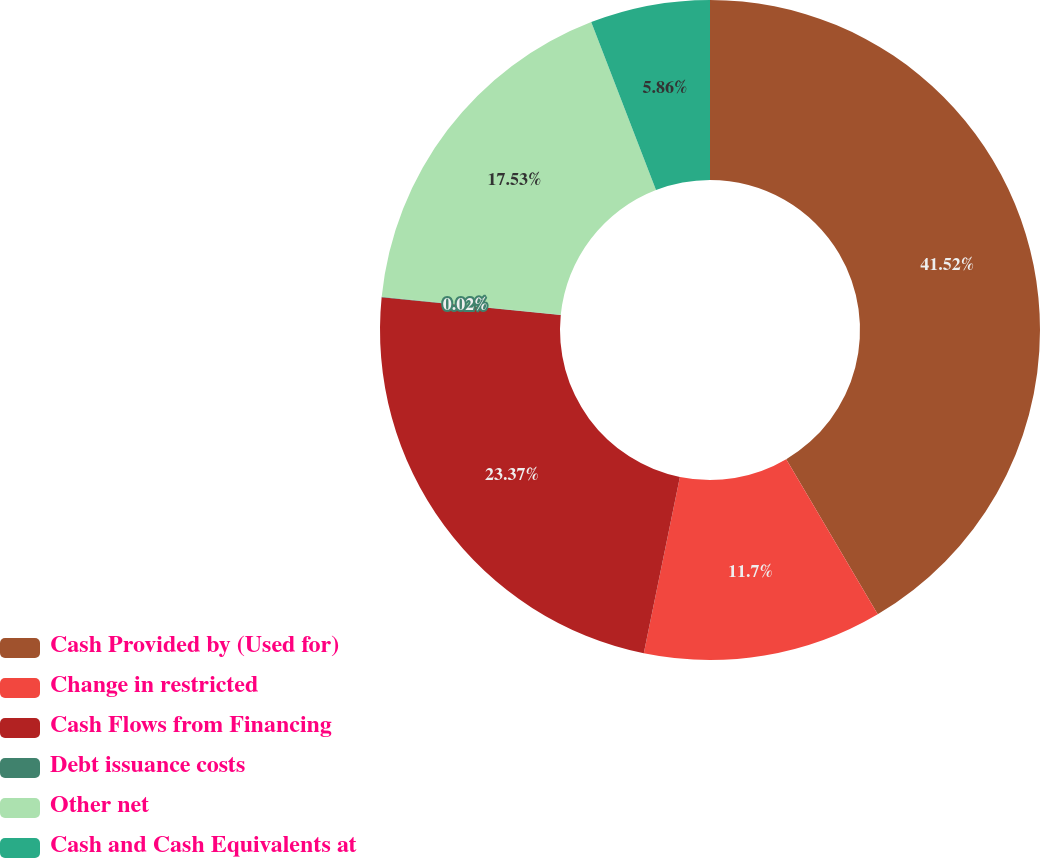Convert chart. <chart><loc_0><loc_0><loc_500><loc_500><pie_chart><fcel>Cash Provided by (Used for)<fcel>Change in restricted<fcel>Cash Flows from Financing<fcel>Debt issuance costs<fcel>Other net<fcel>Cash and Cash Equivalents at<nl><fcel>41.51%<fcel>11.7%<fcel>23.37%<fcel>0.02%<fcel>17.53%<fcel>5.86%<nl></chart> 